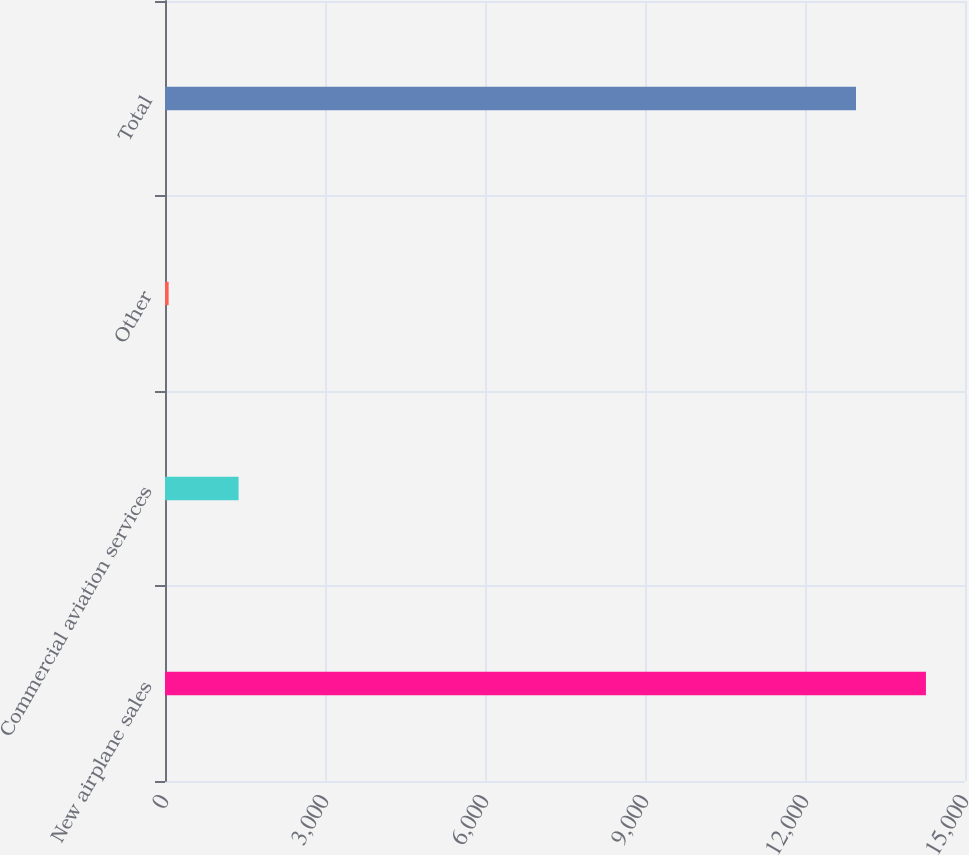<chart> <loc_0><loc_0><loc_500><loc_500><bar_chart><fcel>New airplane sales<fcel>Commercial aviation services<fcel>Other<fcel>Total<nl><fcel>14267.7<fcel>1379.7<fcel>68<fcel>12956<nl></chart> 